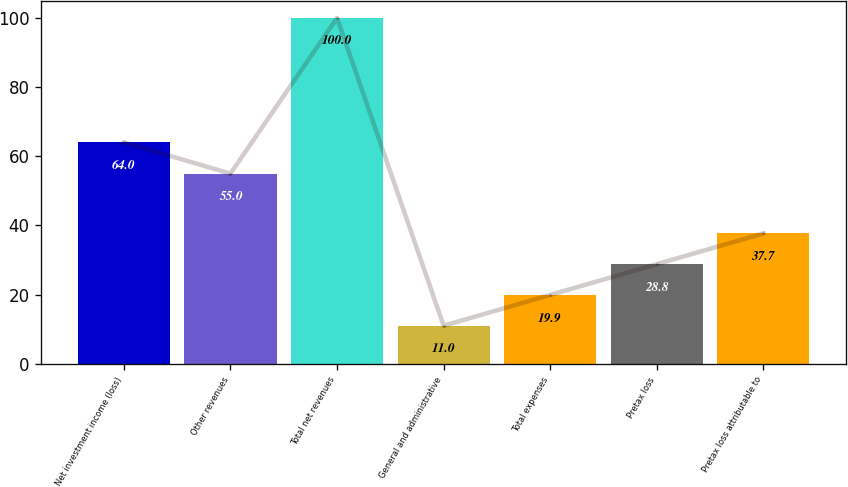<chart> <loc_0><loc_0><loc_500><loc_500><bar_chart><fcel>Net investment income (loss)<fcel>Other revenues<fcel>Total net revenues<fcel>General and administrative<fcel>Total expenses<fcel>Pretax loss<fcel>Pretax loss attributable to<nl><fcel>64<fcel>55<fcel>100<fcel>11<fcel>19.9<fcel>28.8<fcel>37.7<nl></chart> 